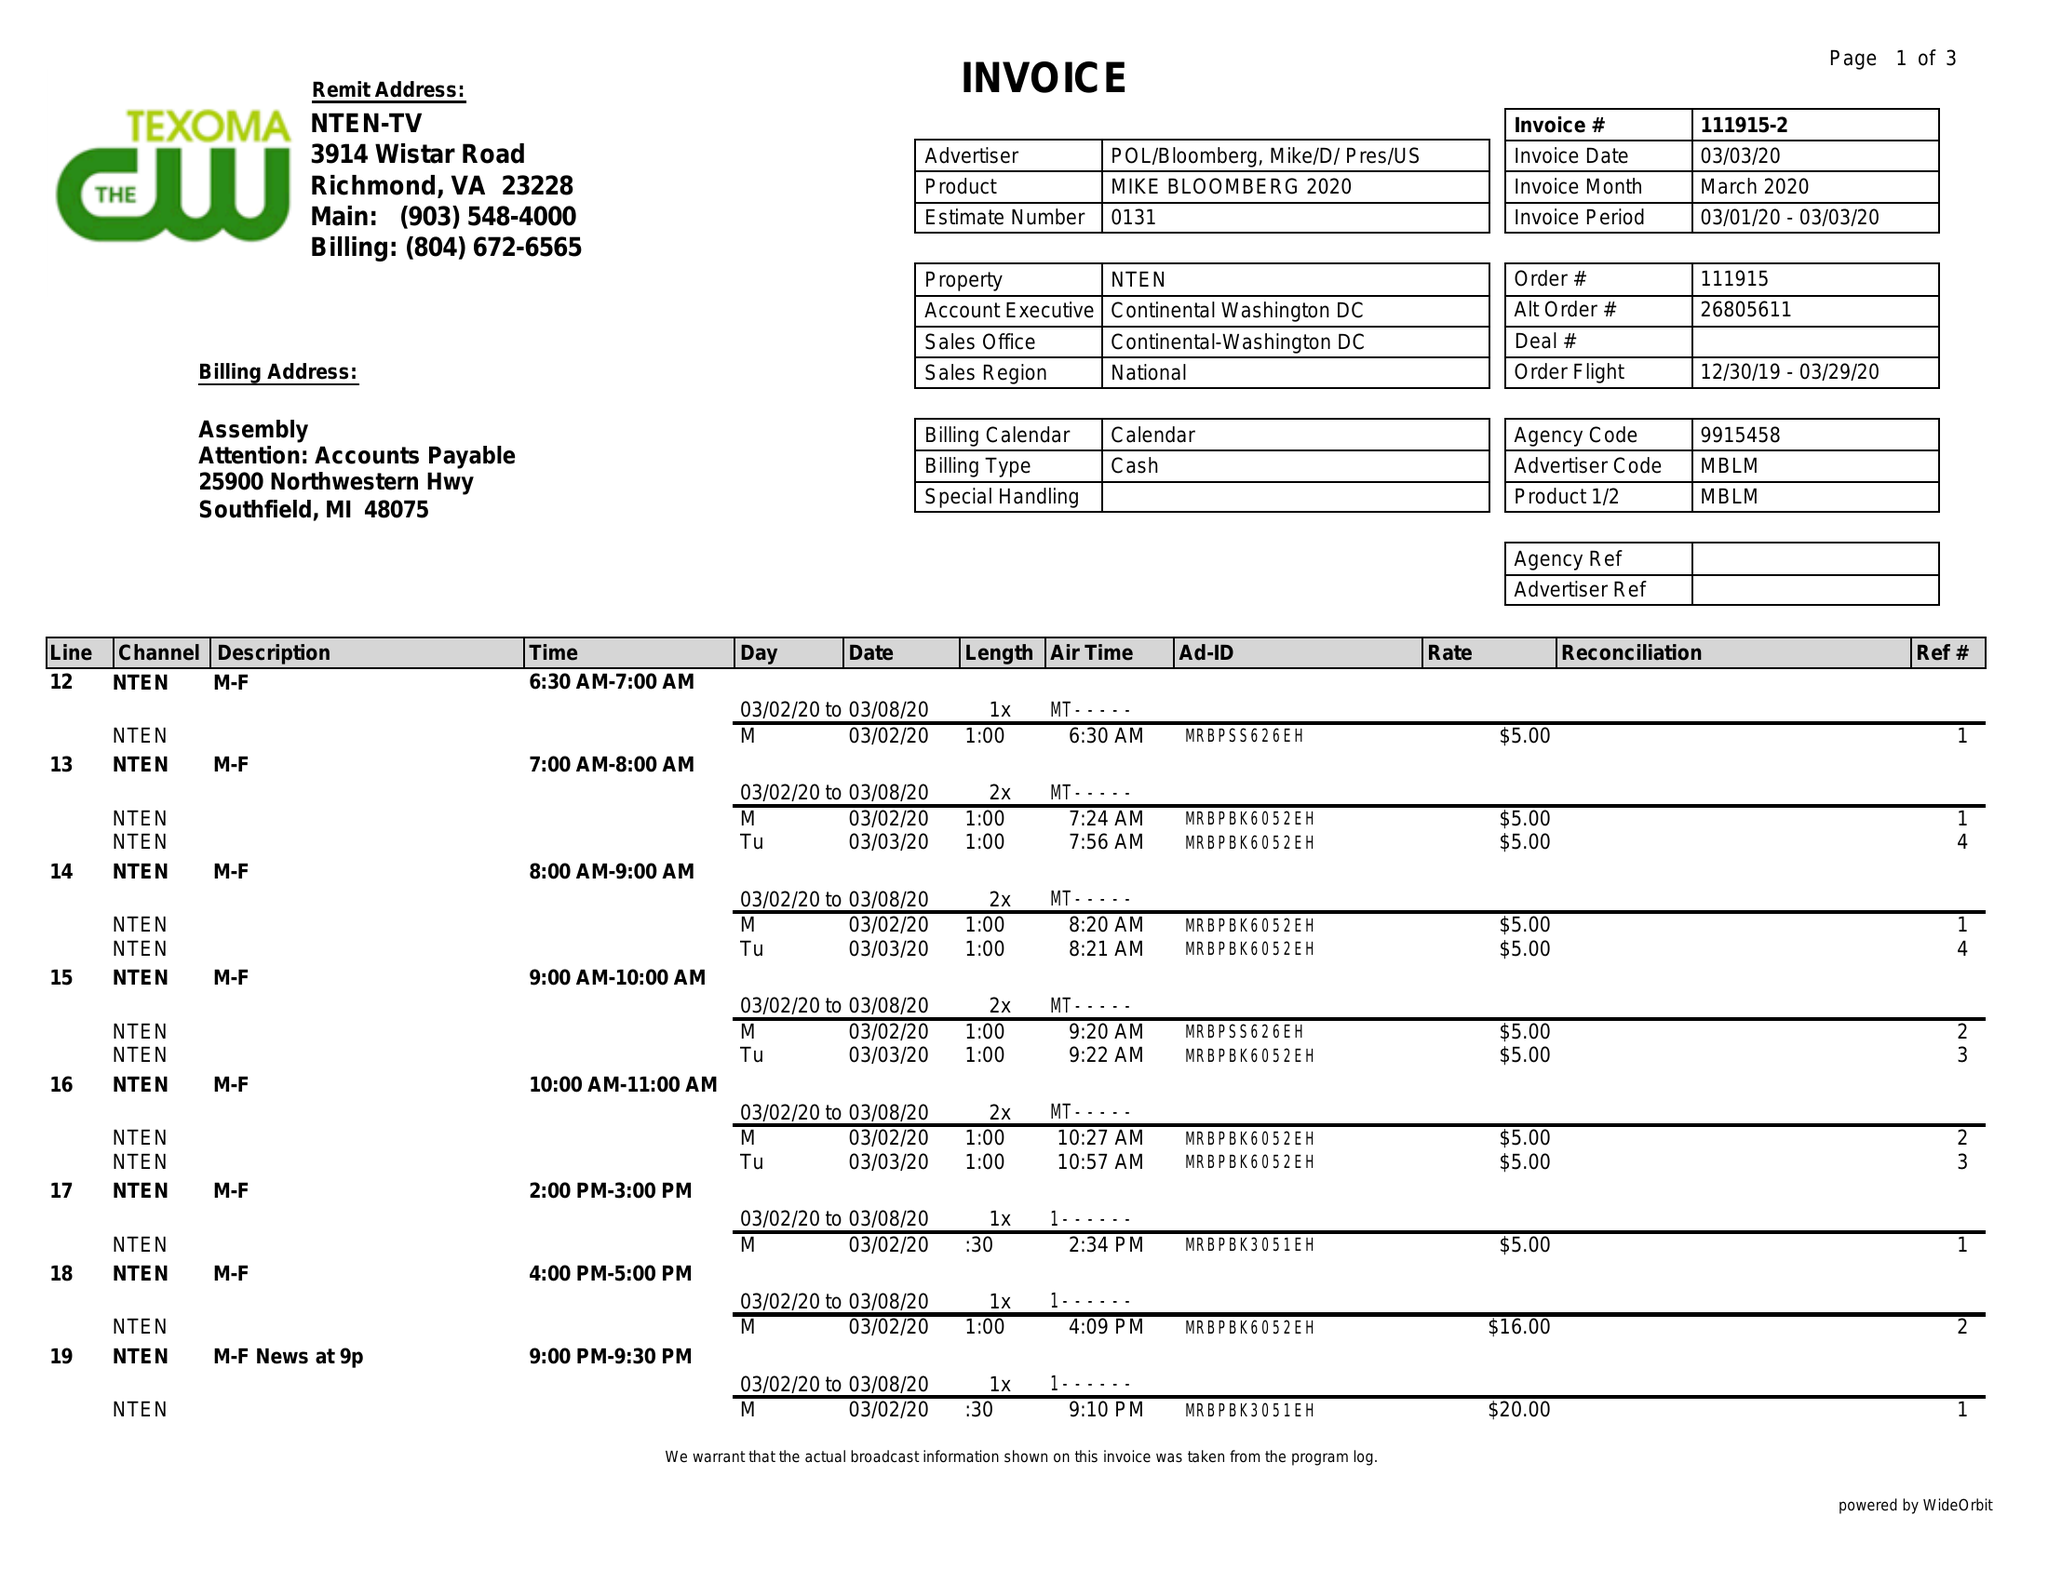What is the value for the flight_from?
Answer the question using a single word or phrase. 12/30/19 